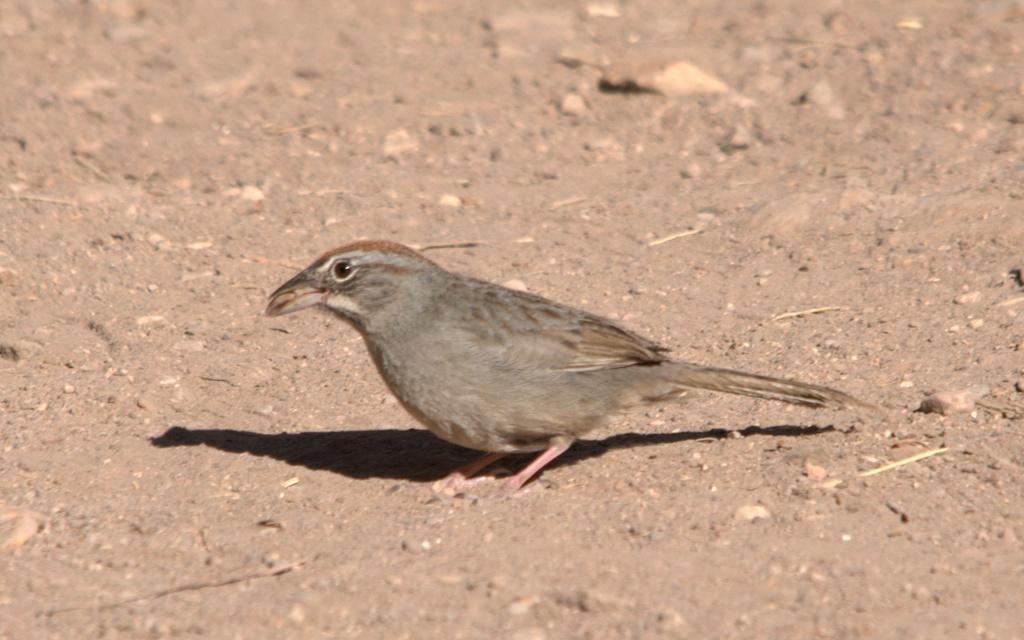Can you describe this image briefly? In this image, in the middle, we can see a bird standing on the land. 